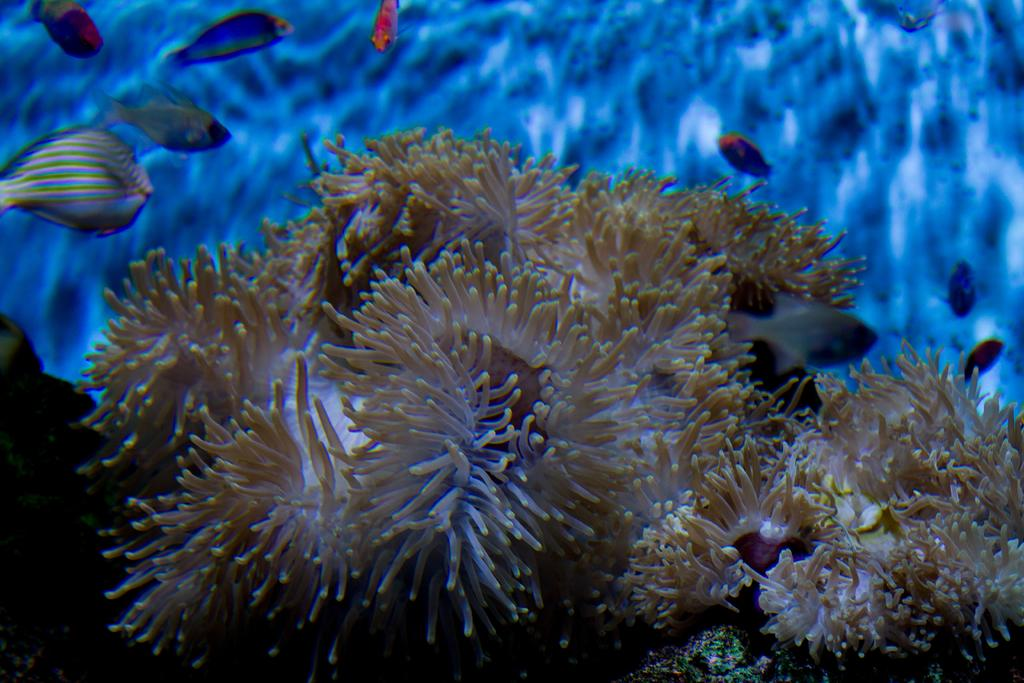What type of plants are in the image? There are sea plants in the image. What are the sea plants located near? The sea plants are near fishes. Where are the fishes in the image? The fishes are in the water. What color is the background of the image? The background of the image is blue. How does the size of the sea plants change in the image? The size of the sea plants does not change in the image; they remain the same size throughout. 